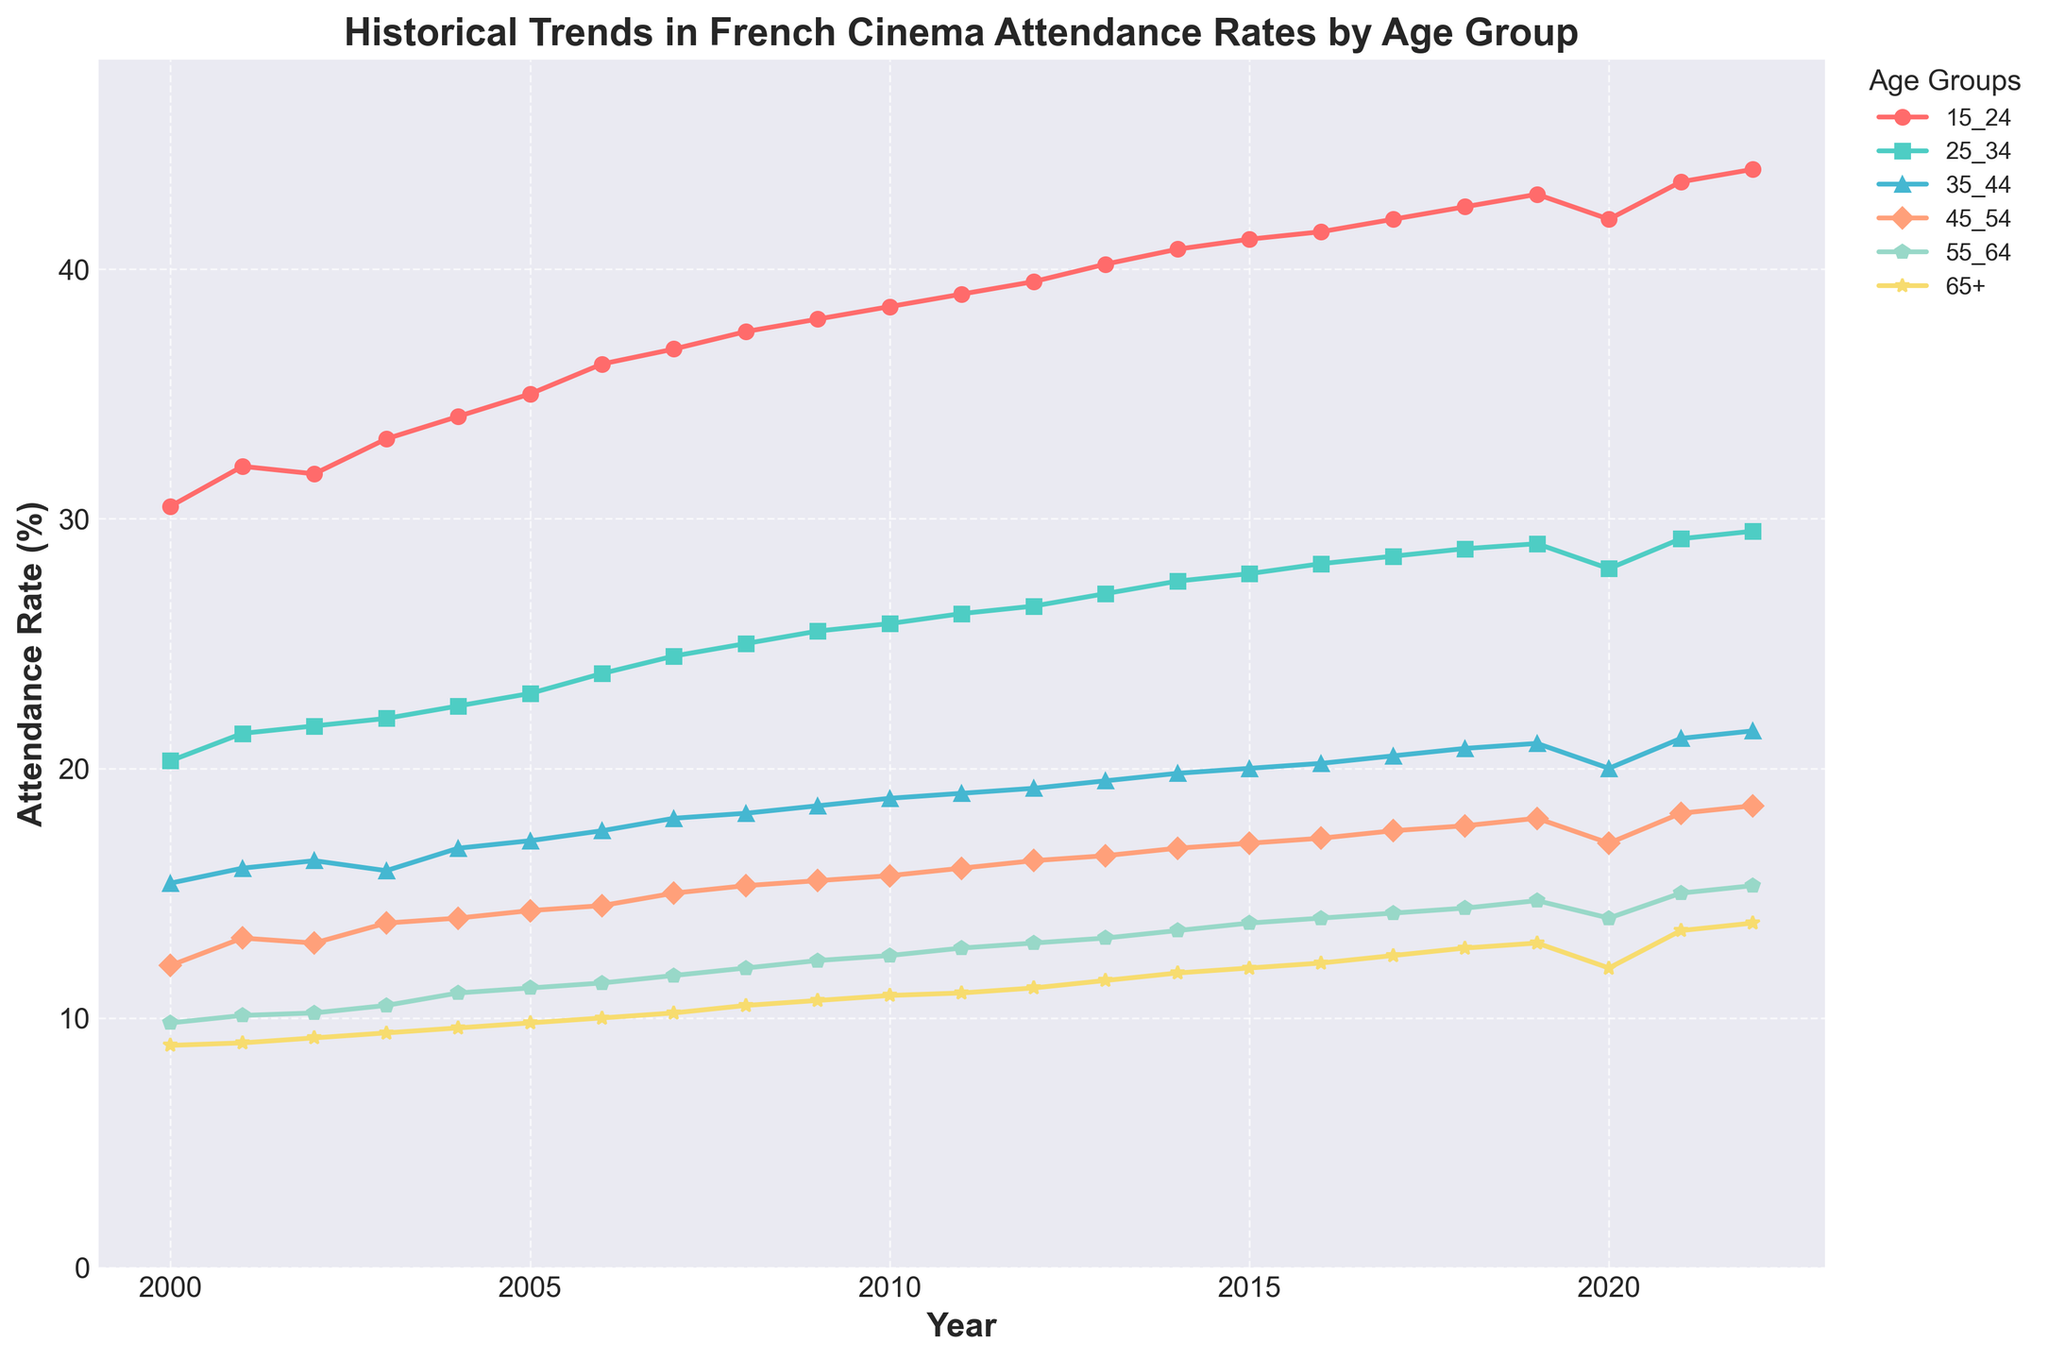What is the title of the plot? The title is located at the top of the plot and reads "Historical Trends in French Cinema Attendance Rates by Age Group".
Answer: Historical Trends in French Cinema Attendance Rates by Age Group Which age group had the highest cinema attendance rate in 2022? By looking at the data points for each age group in the year 2022, the highest value is for the age group 15-24.
Answer: Age group 15-24 Did the attendance rate for the age group 65+ increase or decrease between 2020 and 2022? By observing the plot, compare the attendance rates for the age group 65+ in 2020 and 2022. It increased from 12.0% to 13.8%.
Answer: Increase What's the difference in attendance rates between age group 25-34 and age group 35-44 in 2022? Look at the plot values for each group in 2022 and subtract the attendance rate of age group 35-44 from age group 25-34, which gives: 29.5% - 21.5% = 8.0%.
Answer: 8.0% Which age group showed the most significant increase in cinema attendance from 2000 to 2022? Check the values of all age groups in 2000 and 2022, then calculate the difference for each group. Age group 15-24 increased from 30.5% to 44.0%, which is the largest increase (13.5%).
Answer: Age group 15-24 In what year did the age group 45-54 have an attendance rate of 15%? Locate the data point where the age group 45-54 intersects with 15% on the y-axis. This happens in 2007.
Answer: 2007 What is the average cinema attendance rate for age group 35-44 over the 23 years displayed? Sum the attendance rates for the age group 35-44 over the 23 years, then divide by the number of years: (15.4 + 16.0 + 16.3 + 15.9 + 16.8 + 17.1 + 17.5 + 18.0 + 18.2 + 18.5 + 18.8 + 19.0 + 19.2 + 19.5 + 19.8 + 20.0 + 20.2 + 20.5 + 20.8 + 21.0 + 20.0 + 21.2 + 21.5) / 23 = 18.5%.
Answer: 18.5% What trend did the attendance rates for age group 55-64 show between 2015 and 2018? Observe the data points for age group 55-64 from 2015 to 2018, they show a small but steady increase from 13.8% to 14.4%.
Answer: Steady increase 